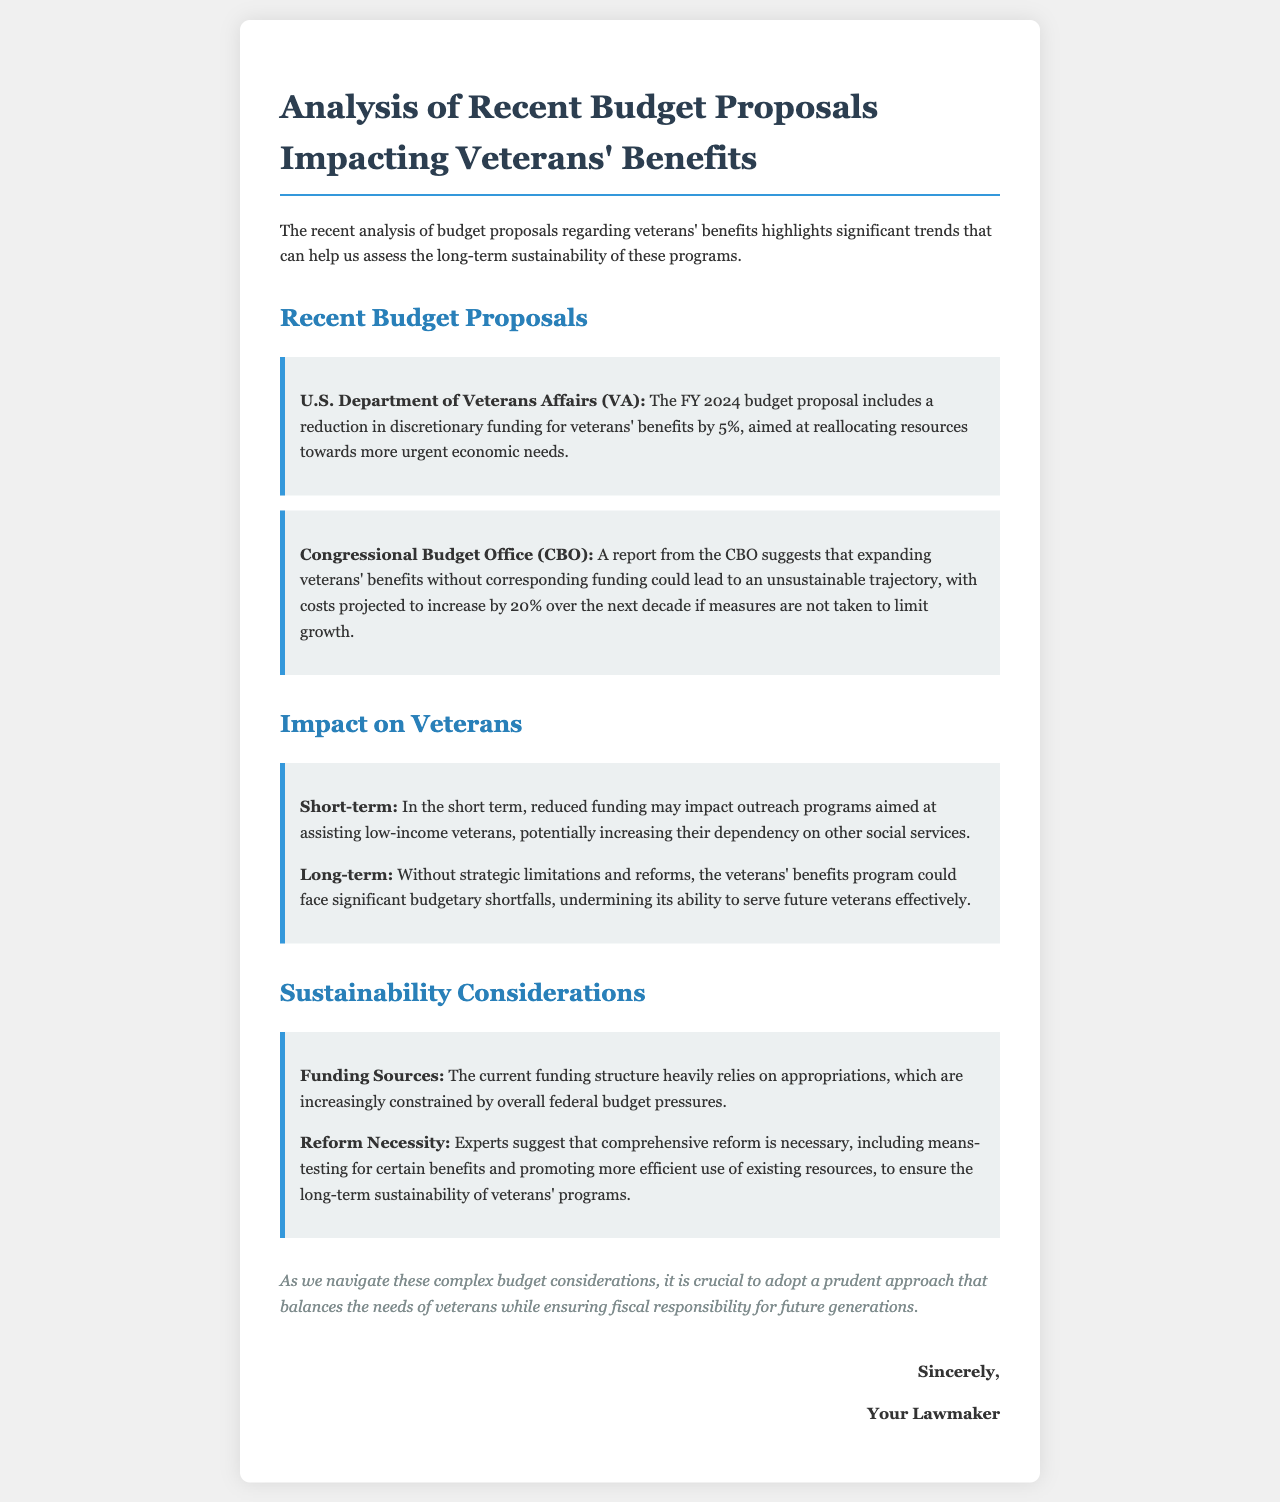What is the proposed reduction in veterans' benefits funding? The proposed reduction in veterans' benefits funding is 5%, as stated in the budget proposal.
Answer: 5% What does the CBO predict about veterans' benefits costs over the next decade? The CBO predicts that costs are projected to increase by 20% over the next decade if measures are not taken.
Answer: 20% What is one potential short-term impact of reduced funding? One potential short-term impact is that it may affect outreach programs aimed at assisting low-income veterans.
Answer: Outreach programs What do experts suggest is necessary for sustainability? Experts suggest that comprehensive reform is necessary for sustainability, including means-testing for certain benefits.
Answer: Comprehensive reform What is a key focus of the FY 2024 budget proposal? The key focus of the FY 2024 budget proposal is reallocating resources towards more urgent economic needs.
Answer: Reallocating resources What could happen without strategic limitations and reforms? Without strategic limitations and reforms, the veterans' benefits program could face significant budgetary shortfalls.
Answer: Significant budgetary shortfalls What color is used for the letter's title? The color used for the letter's title is #2c3e50.
Answer: #2c3e50 What type of letter is this document? This document is an analysis of budget proposals impacting veterans' benefits.
Answer: Analysis letter 